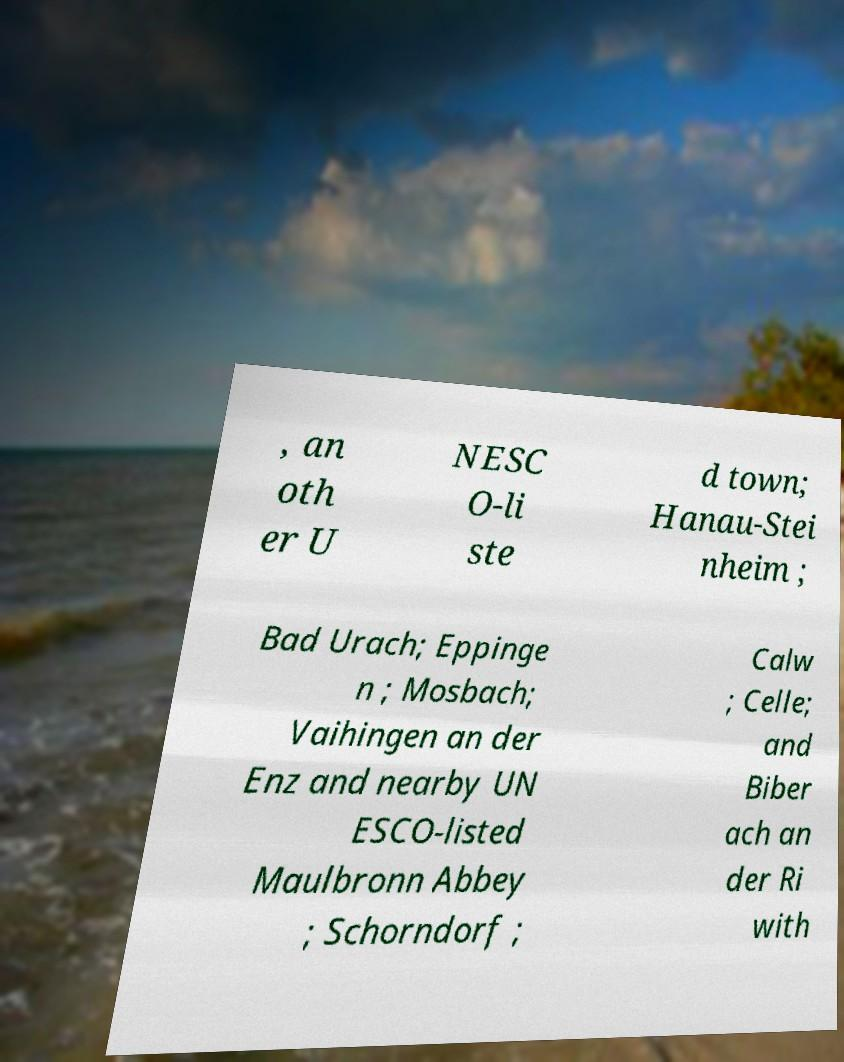Can you accurately transcribe the text from the provided image for me? , an oth er U NESC O-li ste d town; Hanau-Stei nheim ; Bad Urach; Eppinge n ; Mosbach; Vaihingen an der Enz and nearby UN ESCO-listed Maulbronn Abbey ; Schorndorf ; Calw ; Celle; and Biber ach an der Ri with 